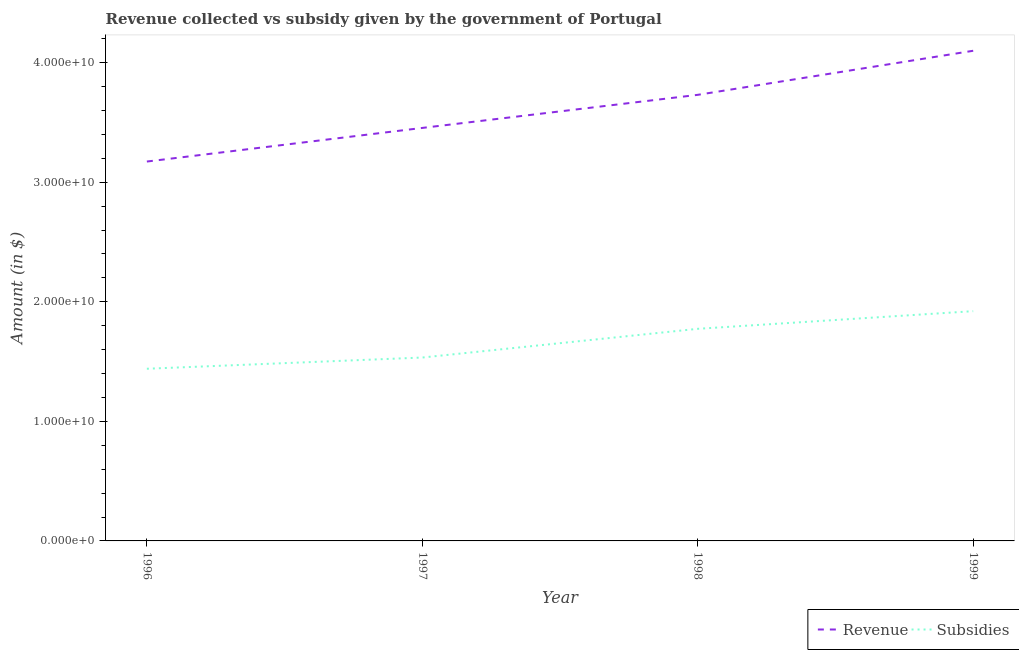Is the number of lines equal to the number of legend labels?
Give a very brief answer. Yes. What is the amount of subsidies given in 1998?
Make the answer very short. 1.77e+1. Across all years, what is the maximum amount of subsidies given?
Make the answer very short. 1.92e+1. Across all years, what is the minimum amount of subsidies given?
Offer a very short reply. 1.44e+1. In which year was the amount of revenue collected maximum?
Provide a succinct answer. 1999. In which year was the amount of revenue collected minimum?
Your answer should be very brief. 1996. What is the total amount of subsidies given in the graph?
Offer a terse response. 6.67e+1. What is the difference between the amount of subsidies given in 1997 and that in 1999?
Your response must be concise. -3.88e+09. What is the difference between the amount of revenue collected in 1996 and the amount of subsidies given in 1997?
Keep it short and to the point. 1.64e+1. What is the average amount of subsidies given per year?
Offer a very short reply. 1.67e+1. In the year 1997, what is the difference between the amount of subsidies given and amount of revenue collected?
Offer a very short reply. -1.92e+1. In how many years, is the amount of revenue collected greater than 16000000000 $?
Your answer should be compact. 4. What is the ratio of the amount of revenue collected in 1996 to that in 1998?
Make the answer very short. 0.85. Is the difference between the amount of subsidies given in 1996 and 1999 greater than the difference between the amount of revenue collected in 1996 and 1999?
Offer a very short reply. Yes. What is the difference between the highest and the second highest amount of revenue collected?
Ensure brevity in your answer.  3.69e+09. What is the difference between the highest and the lowest amount of revenue collected?
Give a very brief answer. 9.26e+09. Does the amount of subsidies given monotonically increase over the years?
Offer a very short reply. Yes. Is the amount of revenue collected strictly greater than the amount of subsidies given over the years?
Your answer should be compact. Yes. Is the amount of revenue collected strictly less than the amount of subsidies given over the years?
Offer a terse response. No. Does the graph contain any zero values?
Provide a short and direct response. No. Does the graph contain grids?
Provide a short and direct response. No. What is the title of the graph?
Offer a very short reply. Revenue collected vs subsidy given by the government of Portugal. Does "Food and tobacco" appear as one of the legend labels in the graph?
Provide a short and direct response. No. What is the label or title of the X-axis?
Ensure brevity in your answer.  Year. What is the label or title of the Y-axis?
Your answer should be compact. Amount (in $). What is the Amount (in $) of Revenue in 1996?
Keep it short and to the point. 3.17e+1. What is the Amount (in $) in Subsidies in 1996?
Provide a short and direct response. 1.44e+1. What is the Amount (in $) of Revenue in 1997?
Your response must be concise. 3.45e+1. What is the Amount (in $) of Subsidies in 1997?
Offer a very short reply. 1.53e+1. What is the Amount (in $) in Revenue in 1998?
Your answer should be very brief. 3.73e+1. What is the Amount (in $) in Subsidies in 1998?
Keep it short and to the point. 1.77e+1. What is the Amount (in $) of Revenue in 1999?
Provide a short and direct response. 4.10e+1. What is the Amount (in $) in Subsidies in 1999?
Offer a terse response. 1.92e+1. Across all years, what is the maximum Amount (in $) of Revenue?
Give a very brief answer. 4.10e+1. Across all years, what is the maximum Amount (in $) of Subsidies?
Provide a short and direct response. 1.92e+1. Across all years, what is the minimum Amount (in $) in Revenue?
Keep it short and to the point. 3.17e+1. Across all years, what is the minimum Amount (in $) in Subsidies?
Your response must be concise. 1.44e+1. What is the total Amount (in $) of Revenue in the graph?
Your answer should be very brief. 1.45e+11. What is the total Amount (in $) in Subsidies in the graph?
Make the answer very short. 6.67e+1. What is the difference between the Amount (in $) of Revenue in 1996 and that in 1997?
Provide a succinct answer. -2.81e+09. What is the difference between the Amount (in $) in Subsidies in 1996 and that in 1997?
Provide a succinct answer. -9.39e+08. What is the difference between the Amount (in $) in Revenue in 1996 and that in 1998?
Offer a very short reply. -5.58e+09. What is the difference between the Amount (in $) in Subsidies in 1996 and that in 1998?
Provide a short and direct response. -3.34e+09. What is the difference between the Amount (in $) in Revenue in 1996 and that in 1999?
Give a very brief answer. -9.26e+09. What is the difference between the Amount (in $) in Subsidies in 1996 and that in 1999?
Provide a short and direct response. -4.82e+09. What is the difference between the Amount (in $) of Revenue in 1997 and that in 1998?
Make the answer very short. -2.77e+09. What is the difference between the Amount (in $) in Subsidies in 1997 and that in 1998?
Offer a very short reply. -2.40e+09. What is the difference between the Amount (in $) of Revenue in 1997 and that in 1999?
Keep it short and to the point. -6.45e+09. What is the difference between the Amount (in $) in Subsidies in 1997 and that in 1999?
Your answer should be very brief. -3.88e+09. What is the difference between the Amount (in $) in Revenue in 1998 and that in 1999?
Your answer should be compact. -3.69e+09. What is the difference between the Amount (in $) in Subsidies in 1998 and that in 1999?
Make the answer very short. -1.48e+09. What is the difference between the Amount (in $) of Revenue in 1996 and the Amount (in $) of Subsidies in 1997?
Your answer should be compact. 1.64e+1. What is the difference between the Amount (in $) of Revenue in 1996 and the Amount (in $) of Subsidies in 1998?
Your response must be concise. 1.40e+1. What is the difference between the Amount (in $) of Revenue in 1996 and the Amount (in $) of Subsidies in 1999?
Your answer should be compact. 1.25e+1. What is the difference between the Amount (in $) of Revenue in 1997 and the Amount (in $) of Subsidies in 1998?
Provide a succinct answer. 1.68e+1. What is the difference between the Amount (in $) of Revenue in 1997 and the Amount (in $) of Subsidies in 1999?
Your answer should be compact. 1.53e+1. What is the difference between the Amount (in $) of Revenue in 1998 and the Amount (in $) of Subsidies in 1999?
Make the answer very short. 1.81e+1. What is the average Amount (in $) in Revenue per year?
Keep it short and to the point. 3.61e+1. What is the average Amount (in $) in Subsidies per year?
Provide a succinct answer. 1.67e+1. In the year 1996, what is the difference between the Amount (in $) of Revenue and Amount (in $) of Subsidies?
Make the answer very short. 1.73e+1. In the year 1997, what is the difference between the Amount (in $) in Revenue and Amount (in $) in Subsidies?
Provide a short and direct response. 1.92e+1. In the year 1998, what is the difference between the Amount (in $) of Revenue and Amount (in $) of Subsidies?
Provide a short and direct response. 1.96e+1. In the year 1999, what is the difference between the Amount (in $) in Revenue and Amount (in $) in Subsidies?
Keep it short and to the point. 2.18e+1. What is the ratio of the Amount (in $) in Revenue in 1996 to that in 1997?
Make the answer very short. 0.92. What is the ratio of the Amount (in $) in Subsidies in 1996 to that in 1997?
Offer a very short reply. 0.94. What is the ratio of the Amount (in $) in Revenue in 1996 to that in 1998?
Make the answer very short. 0.85. What is the ratio of the Amount (in $) of Subsidies in 1996 to that in 1998?
Provide a short and direct response. 0.81. What is the ratio of the Amount (in $) of Revenue in 1996 to that in 1999?
Provide a short and direct response. 0.77. What is the ratio of the Amount (in $) of Subsidies in 1996 to that in 1999?
Your response must be concise. 0.75. What is the ratio of the Amount (in $) in Revenue in 1997 to that in 1998?
Make the answer very short. 0.93. What is the ratio of the Amount (in $) of Subsidies in 1997 to that in 1998?
Give a very brief answer. 0.86. What is the ratio of the Amount (in $) of Revenue in 1997 to that in 1999?
Your answer should be very brief. 0.84. What is the ratio of the Amount (in $) in Subsidies in 1997 to that in 1999?
Make the answer very short. 0.8. What is the ratio of the Amount (in $) of Revenue in 1998 to that in 1999?
Give a very brief answer. 0.91. What is the ratio of the Amount (in $) in Subsidies in 1998 to that in 1999?
Make the answer very short. 0.92. What is the difference between the highest and the second highest Amount (in $) in Revenue?
Provide a short and direct response. 3.69e+09. What is the difference between the highest and the second highest Amount (in $) in Subsidies?
Provide a short and direct response. 1.48e+09. What is the difference between the highest and the lowest Amount (in $) of Revenue?
Make the answer very short. 9.26e+09. What is the difference between the highest and the lowest Amount (in $) in Subsidies?
Give a very brief answer. 4.82e+09. 